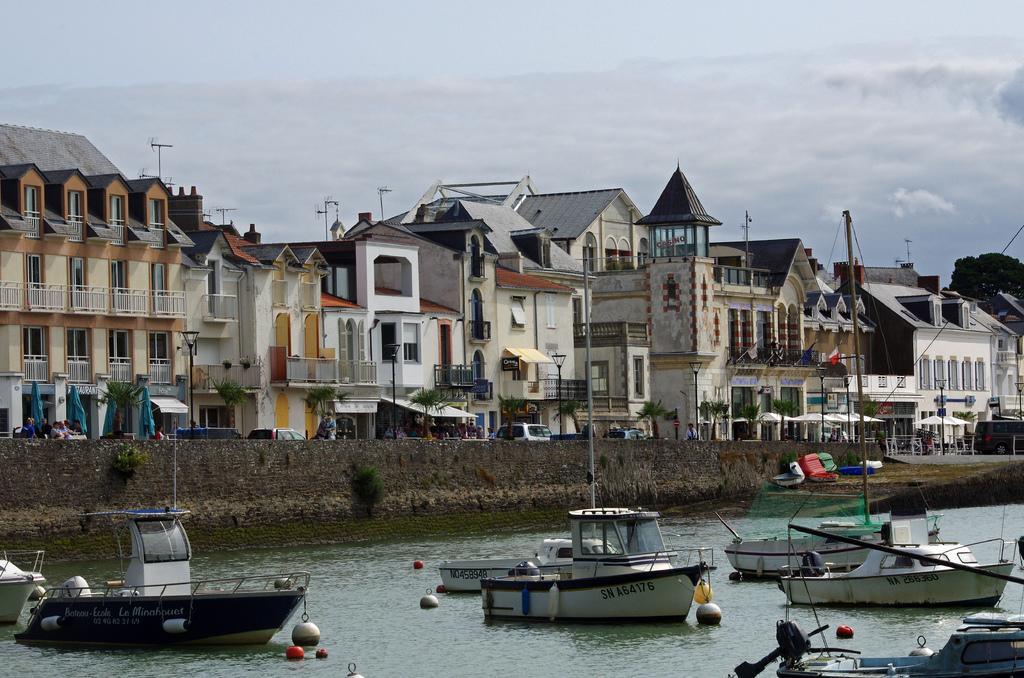Please provide a concise description of this image. In the picture there is a river with boats and at the behind we can a wall and wall behind we can see the buildings and on the backside of the buildings we can see the electric poles. And the sky is cloudy. On the wall we can see trees. 